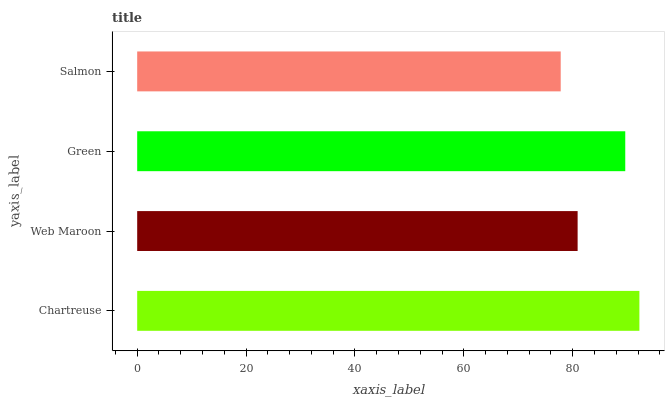Is Salmon the minimum?
Answer yes or no. Yes. Is Chartreuse the maximum?
Answer yes or no. Yes. Is Web Maroon the minimum?
Answer yes or no. No. Is Web Maroon the maximum?
Answer yes or no. No. Is Chartreuse greater than Web Maroon?
Answer yes or no. Yes. Is Web Maroon less than Chartreuse?
Answer yes or no. Yes. Is Web Maroon greater than Chartreuse?
Answer yes or no. No. Is Chartreuse less than Web Maroon?
Answer yes or no. No. Is Green the high median?
Answer yes or no. Yes. Is Web Maroon the low median?
Answer yes or no. Yes. Is Salmon the high median?
Answer yes or no. No. Is Salmon the low median?
Answer yes or no. No. 